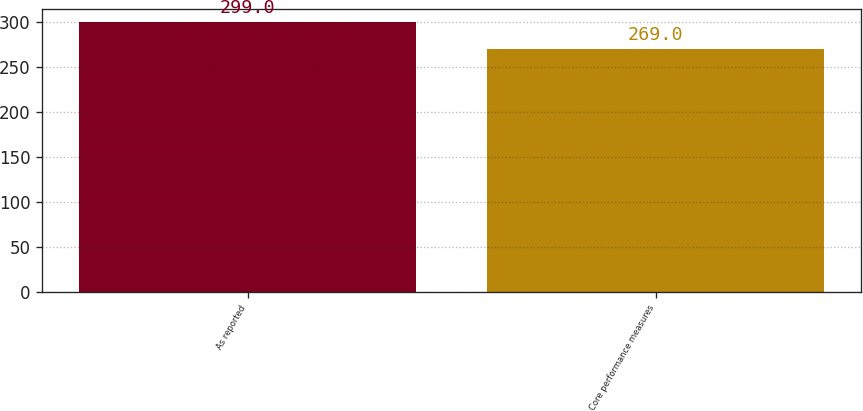Convert chart. <chart><loc_0><loc_0><loc_500><loc_500><bar_chart><fcel>As reported<fcel>Core performance measures<nl><fcel>299<fcel>269<nl></chart> 